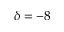<formula> <loc_0><loc_0><loc_500><loc_500>\delta = - 8</formula> 